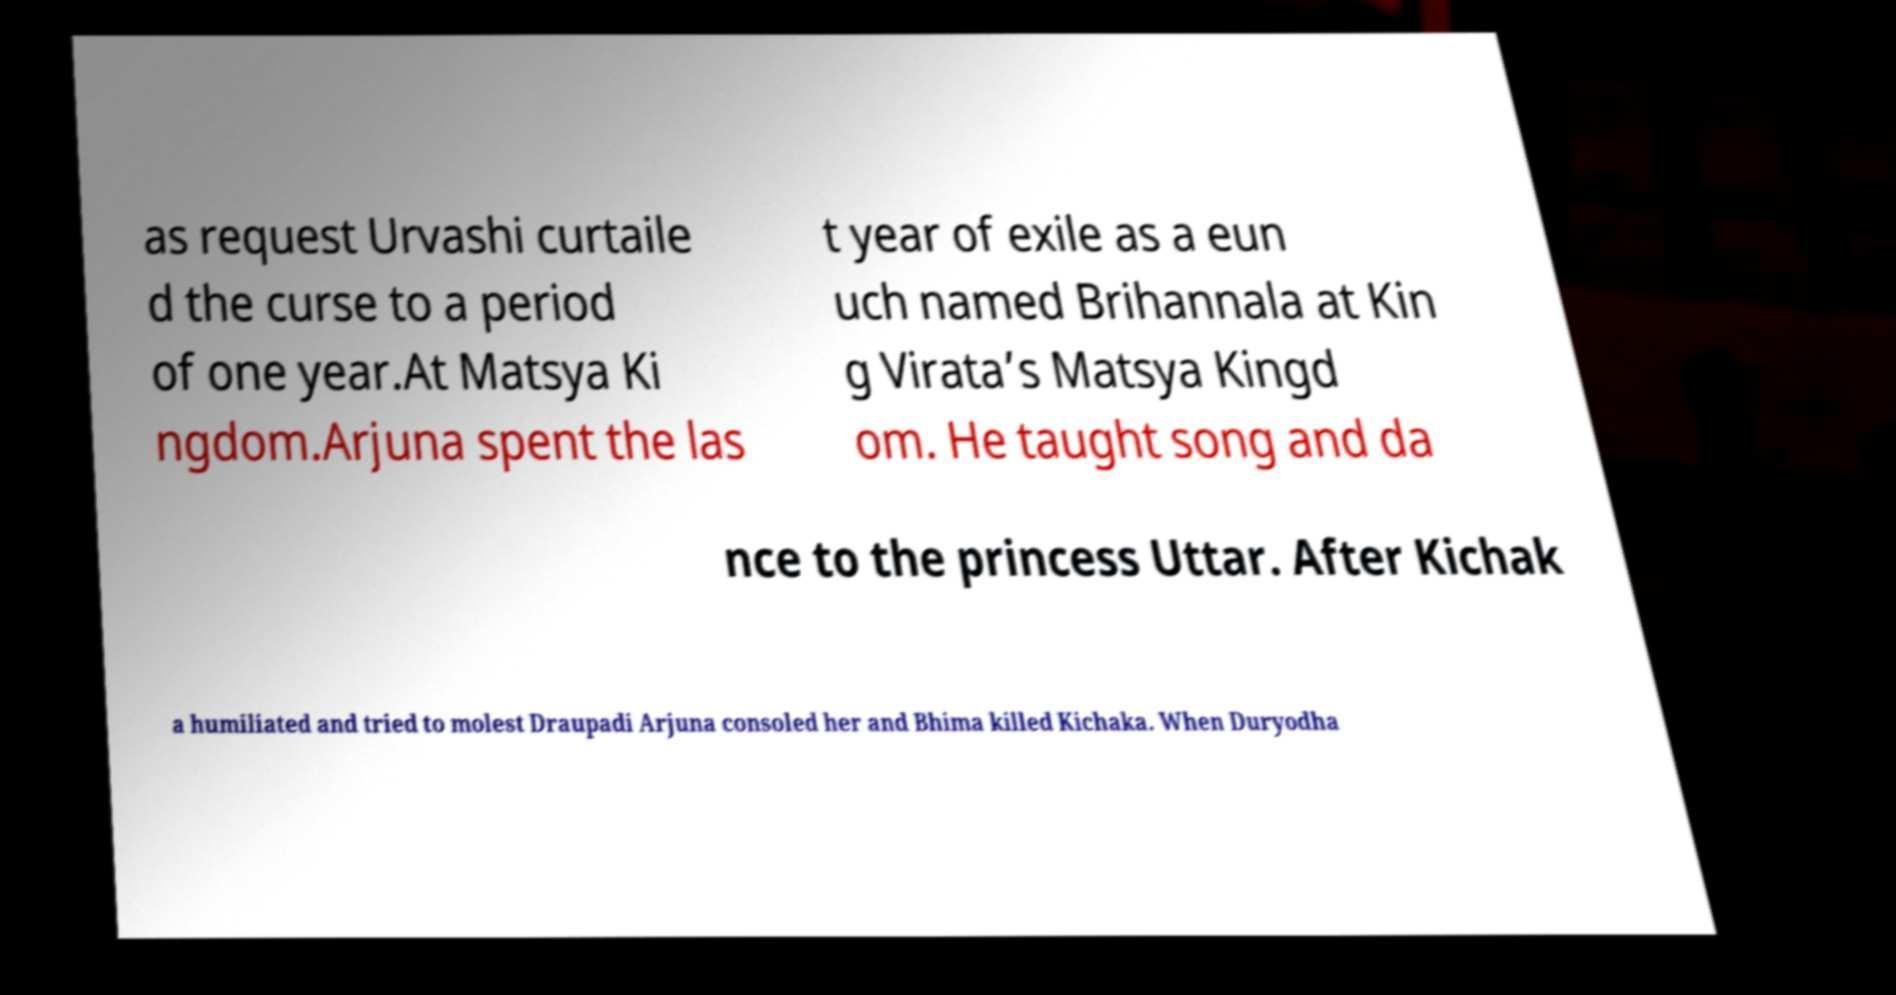For documentation purposes, I need the text within this image transcribed. Could you provide that? as request Urvashi curtaile d the curse to a period of one year.At Matsya Ki ngdom.Arjuna spent the las t year of exile as a eun uch named Brihannala at Kin g Virata’s Matsya Kingd om. He taught song and da nce to the princess Uttar. After Kichak a humiliated and tried to molest Draupadi Arjuna consoled her and Bhima killed Kichaka. When Duryodha 